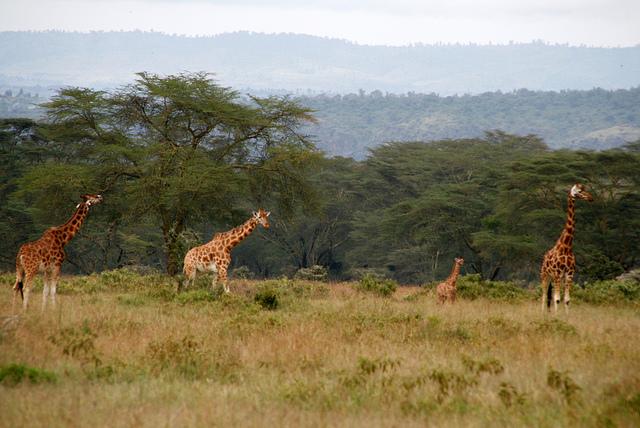Are the giraffes playing with each other?
Keep it brief. No. How many elephants here?
Be succinct. 0. What are these animals?
Give a very brief answer. Giraffes. Where are the giraffes?
Short answer required. Savannah. How many giraffes are in the photo?
Quick response, please. 4. 